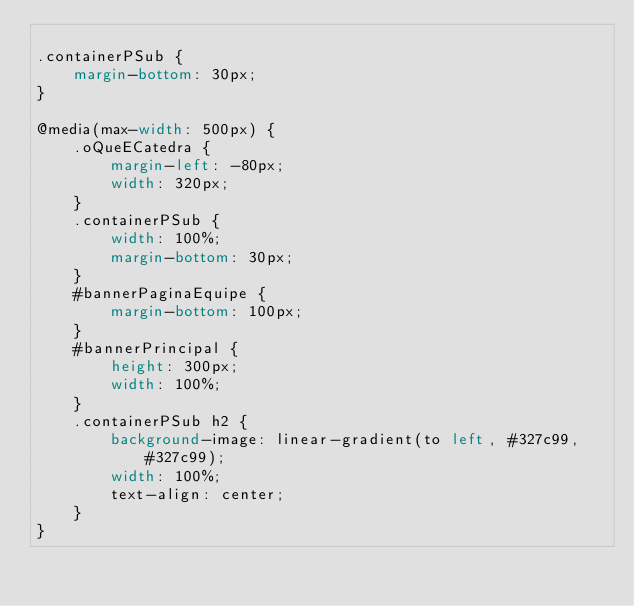<code> <loc_0><loc_0><loc_500><loc_500><_CSS_>
.containerPSub {
    margin-bottom: 30px;
}

@media(max-width: 500px) {
    .oQueECatedra {
        margin-left: -80px;
        width: 320px;
    }
    .containerPSub {
        width: 100%;
        margin-bottom: 30px;
    }
    #bannerPaginaEquipe {
        margin-bottom: 100px;
    }
    #bannerPrincipal {
        height: 300px;
        width: 100%;
    }
    .containerPSub h2 {
        background-image: linear-gradient(to left, #327c99, #327c99);
        width: 100%;
        text-align: center;
    }
}</code> 